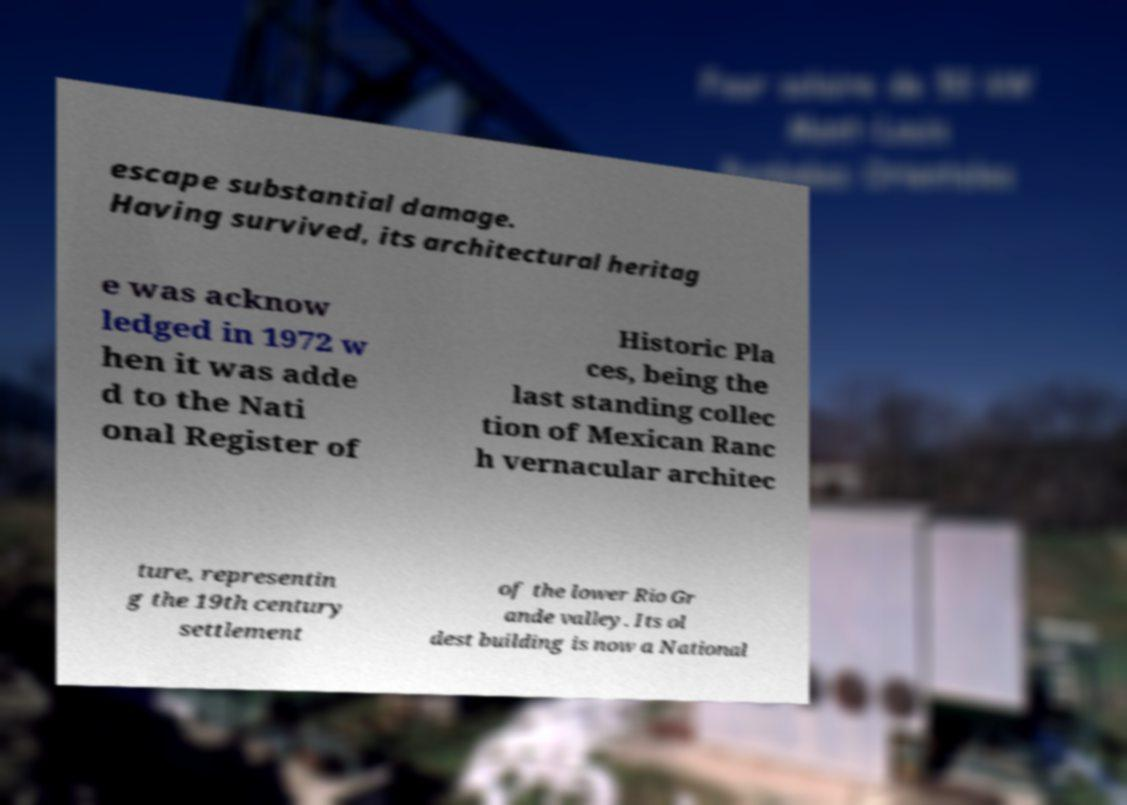There's text embedded in this image that I need extracted. Can you transcribe it verbatim? escape substantial damage. Having survived, its architectural heritag e was acknow ledged in 1972 w hen it was adde d to the Nati onal Register of Historic Pla ces, being the last standing collec tion of Mexican Ranc h vernacular architec ture, representin g the 19th century settlement of the lower Rio Gr ande valley. Its ol dest building is now a National 